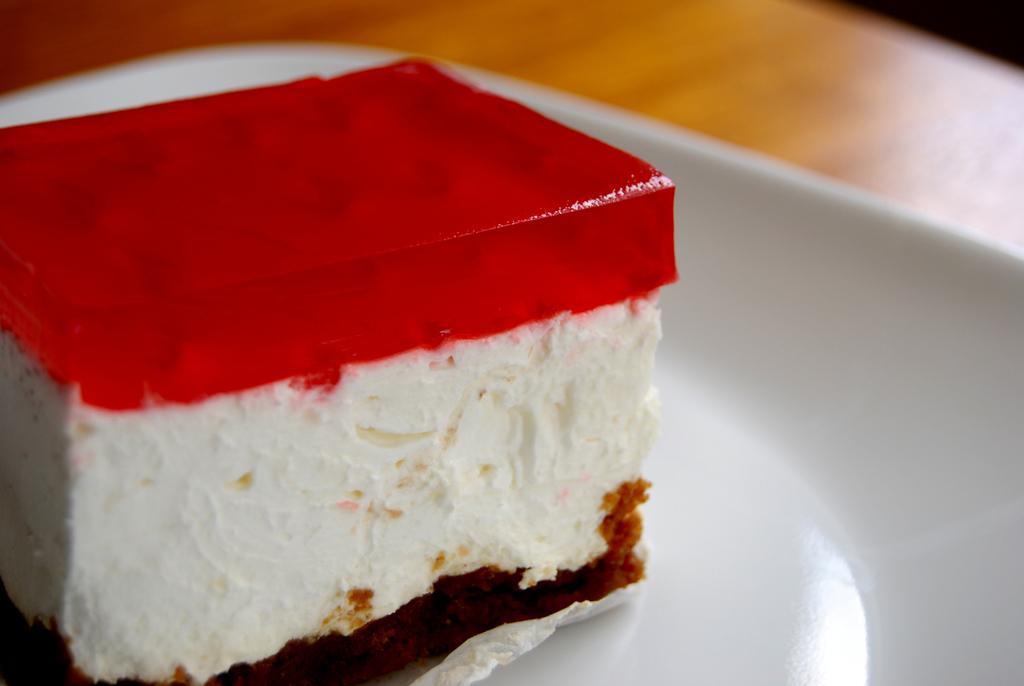Please provide a concise description of this image. In this image, I can see a piece of cake on the plate. I think this plate is placed on the wooden board. 